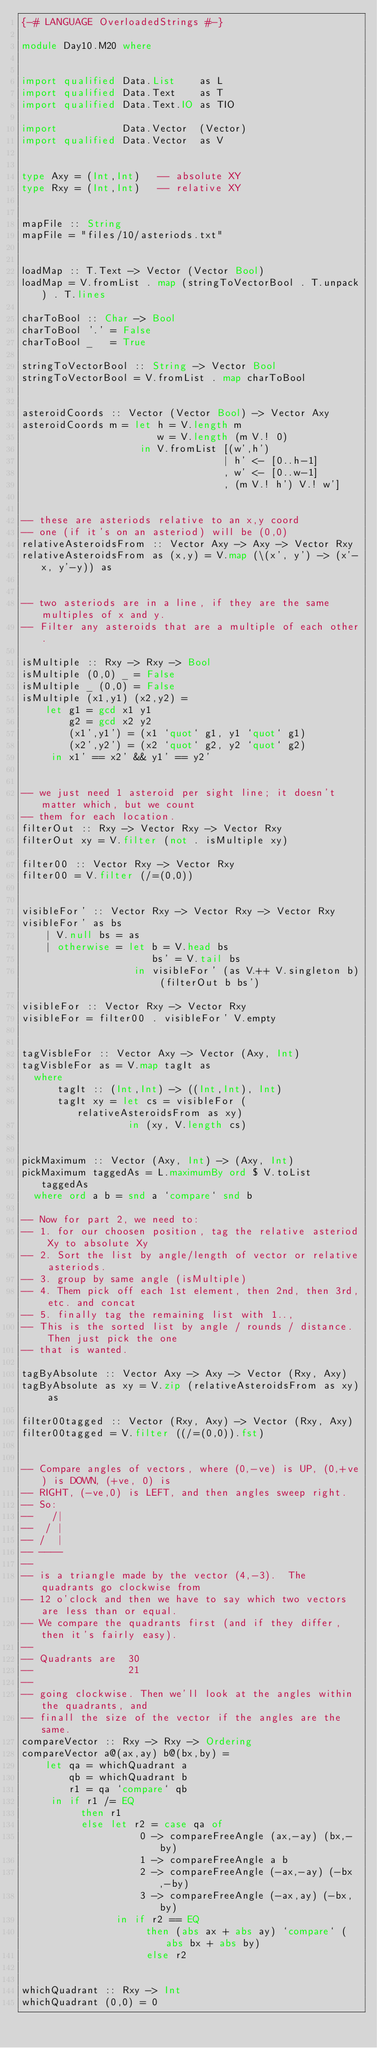Convert code to text. <code><loc_0><loc_0><loc_500><loc_500><_Haskell_>{-# LANGUAGE OverloadedStrings #-}

module Day10.M20 where


import qualified Data.List    as L
import qualified Data.Text    as T
import qualified Data.Text.IO as TIO

import           Data.Vector  (Vector)
import qualified Data.Vector  as V


type Axy = (Int,Int)   -- absolute XY
type Rxy = (Int,Int)   -- relative XY


mapFile :: String
mapFile = "files/10/asteriods.txt"


loadMap :: T.Text -> Vector (Vector Bool)
loadMap = V.fromList . map (stringToVectorBool . T.unpack) . T.lines

charToBool :: Char -> Bool
charToBool '.' = False
charToBool _   = True

stringToVectorBool :: String -> Vector Bool
stringToVectorBool = V.fromList . map charToBool


asteroidCoords :: Vector (Vector Bool) -> Vector Axy
asteroidCoords m = let h = V.length m
                       w = V.length (m V.! 0)
                    in V.fromList [(w',h')
                                  | h' <- [0..h-1]
                                  , w' <- [0..w-1]
                                  , (m V.! h') V.! w']


-- these are asteriods relative to an x,y coord
-- one (if it's on an asteriod) will be (0,0)
relativeAsteroidsFrom :: Vector Axy -> Axy -> Vector Rxy
relativeAsteroidsFrom as (x,y) = V.map (\(x', y') -> (x'-x, y'-y)) as


-- two asteriods are in a line, if they are the same multiples of x and y.
-- Filter any asteroids that are a multiple of each other.

isMultiple :: Rxy -> Rxy -> Bool
isMultiple (0,0) _ = False
isMultiple _ (0,0) = False
isMultiple (x1,y1) (x2,y2) =
    let g1 = gcd x1 y1
        g2 = gcd x2 y2
        (x1',y1') = (x1 `quot` g1, y1 `quot` g1)
        (x2',y2') = (x2 `quot` g2, y2 `quot` g2)
     in x1' == x2' && y1' == y2'


-- we just need 1 asteroid per sight line; it doesn't matter which, but we count
-- them for each location.
filterOut :: Rxy -> Vector Rxy -> Vector Rxy
filterOut xy = V.filter (not . isMultiple xy)

filter00 :: Vector Rxy -> Vector Rxy
filter00 = V.filter (/=(0,0))


visibleFor' :: Vector Rxy -> Vector Rxy -> Vector Rxy
visibleFor' as bs
    | V.null bs = as
    | otherwise = let b = V.head bs
                      bs' = V.tail bs
                   in visibleFor' (as V.++ V.singleton b) (filterOut b bs')

visibleFor :: Vector Rxy -> Vector Rxy
visibleFor = filter00 . visibleFor' V.empty


tagVisbleFor :: Vector Axy -> Vector (Axy, Int)
tagVisbleFor as = V.map tagIt as
  where
      tagIt :: (Int,Int) -> ((Int,Int), Int)
      tagIt xy = let cs = visibleFor (relativeAsteroidsFrom as xy)
                  in (xy, V.length cs)


pickMaximum :: Vector (Axy, Int) -> (Axy, Int)
pickMaximum taggedAs = L.maximumBy ord $ V.toList taggedAs
  where ord a b = snd a `compare` snd b

-- Now for part 2, we need to:
-- 1. for our choosen position, tag the relative asteriod Xy to absolute Xy
-- 2. Sort the list by angle/length of vector or relative asteriods.
-- 3. group by same angle (isMultiple)
-- 4. Them pick off each 1st element, then 2nd, then 3rd, etc. and concat
-- 5. finally tag the remaining list with 1..,
-- This is the sorted list by angle / rounds / distance.  Then just pick the one
-- that is wanted.

tagByAbsolute :: Vector Axy -> Axy -> Vector (Rxy, Axy)
tagByAbsolute as xy = V.zip (relativeAsteroidsFrom as xy) as

filter00tagged :: Vector (Rxy, Axy) -> Vector (Rxy, Axy)
filter00tagged = V.filter ((/=(0,0)).fst)


-- Compare angles of vectors, where (0,-ve) is UP, (0,+ve) is DOWN, (+ve, 0) is
-- RIGHT, (-ve,0) is LEFT, and then angles sweep right.
-- So:
--   /|
--  / |
-- /  |
-- ----
--
-- is a triangle made by the vector (4,-3).  The quadrants go clockwise from
-- 12 o'clock and then we have to say which two vectors are less than or equal.
-- We compare the quadrants first (and if they differ, then it's fairly easy).
--
-- Quadrants are  30
--                21
--
-- going clockwise. Then we'll look at the angles within the quadrants, and
-- finall the size of the vector if the angles are the same.
compareVector :: Rxy -> Rxy -> Ordering
compareVector a@(ax,ay) b@(bx,by) =
    let qa = whichQuadrant a
        qb = whichQuadrant b
        r1 = qa `compare` qb
     in if r1 /= EQ
          then r1
          else let r2 = case qa of
                    0 -> compareFreeAngle (ax,-ay) (bx,-by)
                    1 -> compareFreeAngle a b
                    2 -> compareFreeAngle (-ax,-ay) (-bx,-by)
                    3 -> compareFreeAngle (-ax,ay) (-bx,by)
                in if r2 == EQ
                     then (abs ax + abs ay) `compare` (abs bx + abs by)
                     else r2


whichQuadrant :: Rxy -> Int
whichQuadrant (0,0) = 0</code> 